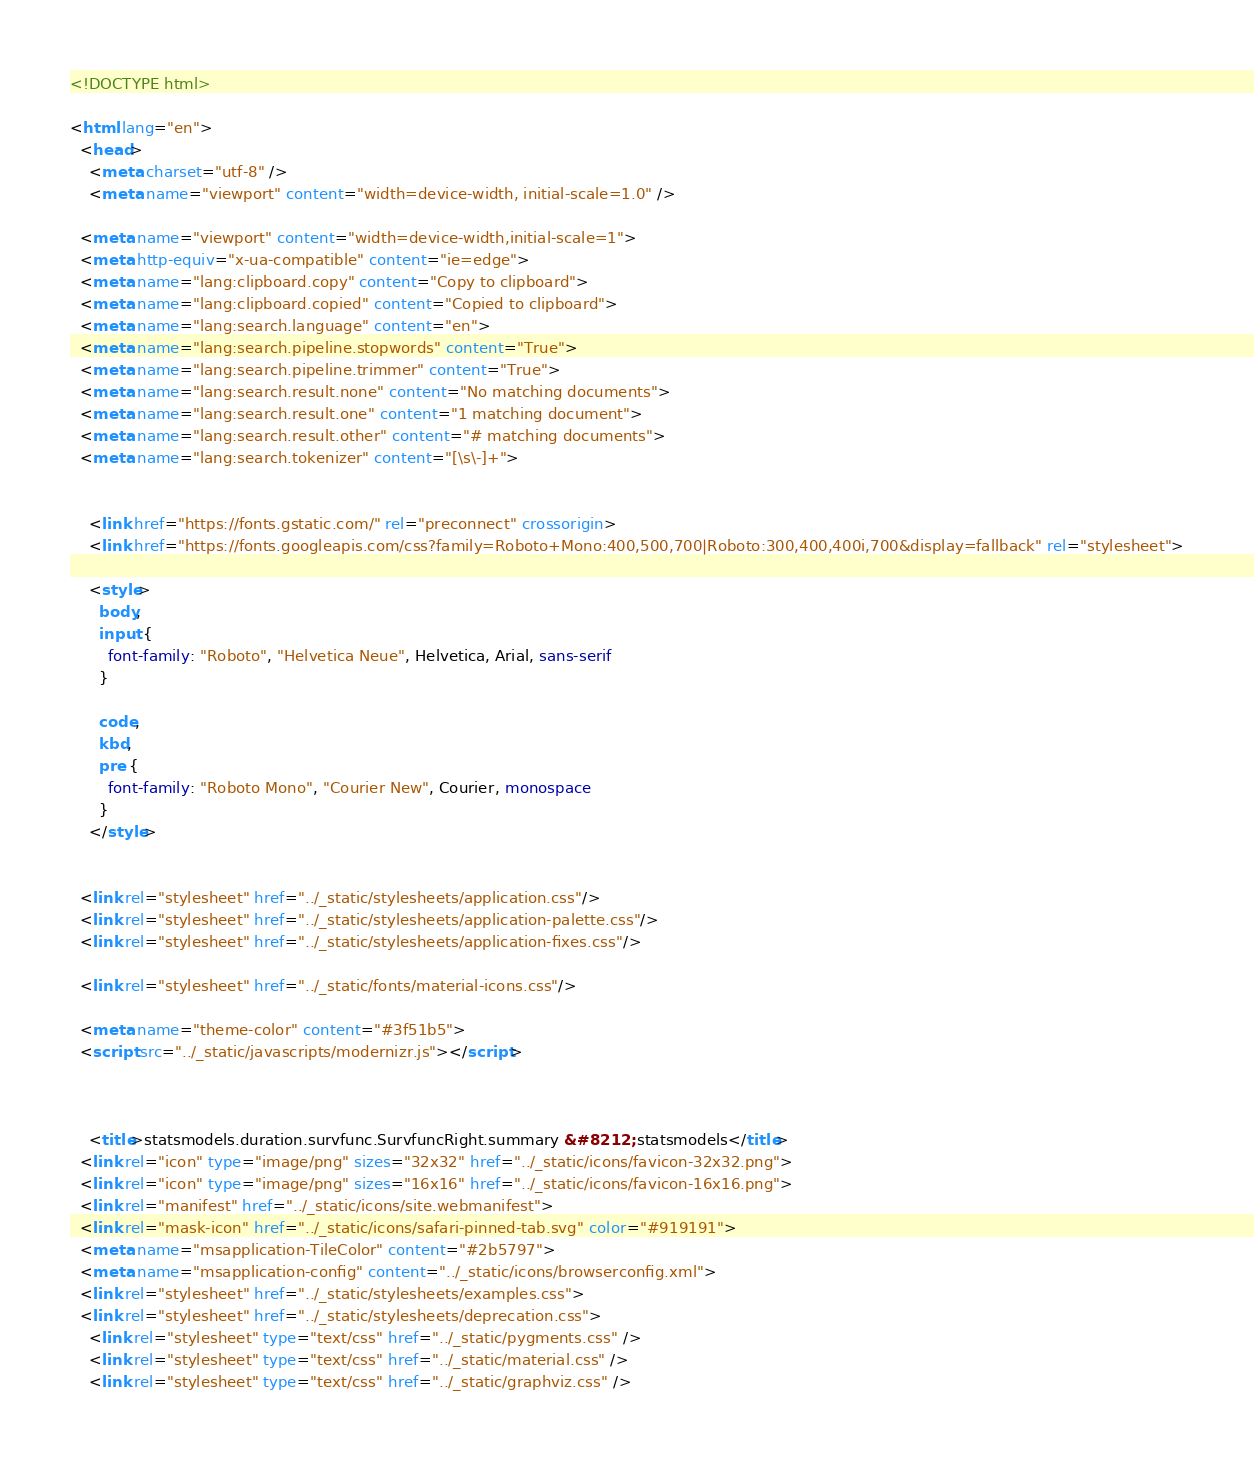<code> <loc_0><loc_0><loc_500><loc_500><_HTML_>

<!DOCTYPE html>

<html lang="en">
  <head>
    <meta charset="utf-8" />
    <meta name="viewport" content="width=device-width, initial-scale=1.0" />
  
  <meta name="viewport" content="width=device-width,initial-scale=1">
  <meta http-equiv="x-ua-compatible" content="ie=edge">
  <meta name="lang:clipboard.copy" content="Copy to clipboard">
  <meta name="lang:clipboard.copied" content="Copied to clipboard">
  <meta name="lang:search.language" content="en">
  <meta name="lang:search.pipeline.stopwords" content="True">
  <meta name="lang:search.pipeline.trimmer" content="True">
  <meta name="lang:search.result.none" content="No matching documents">
  <meta name="lang:search.result.one" content="1 matching document">
  <meta name="lang:search.result.other" content="# matching documents">
  <meta name="lang:search.tokenizer" content="[\s\-]+">

  
    <link href="https://fonts.gstatic.com/" rel="preconnect" crossorigin>
    <link href="https://fonts.googleapis.com/css?family=Roboto+Mono:400,500,700|Roboto:300,400,400i,700&display=fallback" rel="stylesheet">

    <style>
      body,
      input {
        font-family: "Roboto", "Helvetica Neue", Helvetica, Arial, sans-serif
      }

      code,
      kbd,
      pre {
        font-family: "Roboto Mono", "Courier New", Courier, monospace
      }
    </style>
  

  <link rel="stylesheet" href="../_static/stylesheets/application.css"/>
  <link rel="stylesheet" href="../_static/stylesheets/application-palette.css"/>
  <link rel="stylesheet" href="../_static/stylesheets/application-fixes.css"/>
  
  <link rel="stylesheet" href="../_static/fonts/material-icons.css"/>
  
  <meta name="theme-color" content="#3f51b5">
  <script src="../_static/javascripts/modernizr.js"></script>
  
  
  
    <title>statsmodels.duration.survfunc.SurvfuncRight.summary &#8212; statsmodels</title>
  <link rel="icon" type="image/png" sizes="32x32" href="../_static/icons/favicon-32x32.png">
  <link rel="icon" type="image/png" sizes="16x16" href="../_static/icons/favicon-16x16.png">
  <link rel="manifest" href="../_static/icons/site.webmanifest">
  <link rel="mask-icon" href="../_static/icons/safari-pinned-tab.svg" color="#919191">
  <meta name="msapplication-TileColor" content="#2b5797">
  <meta name="msapplication-config" content="../_static/icons/browserconfig.xml">
  <link rel="stylesheet" href="../_static/stylesheets/examples.css">
  <link rel="stylesheet" href="../_static/stylesheets/deprecation.css">
    <link rel="stylesheet" type="text/css" href="../_static/pygments.css" />
    <link rel="stylesheet" type="text/css" href="../_static/material.css" />
    <link rel="stylesheet" type="text/css" href="../_static/graphviz.css" /></code> 